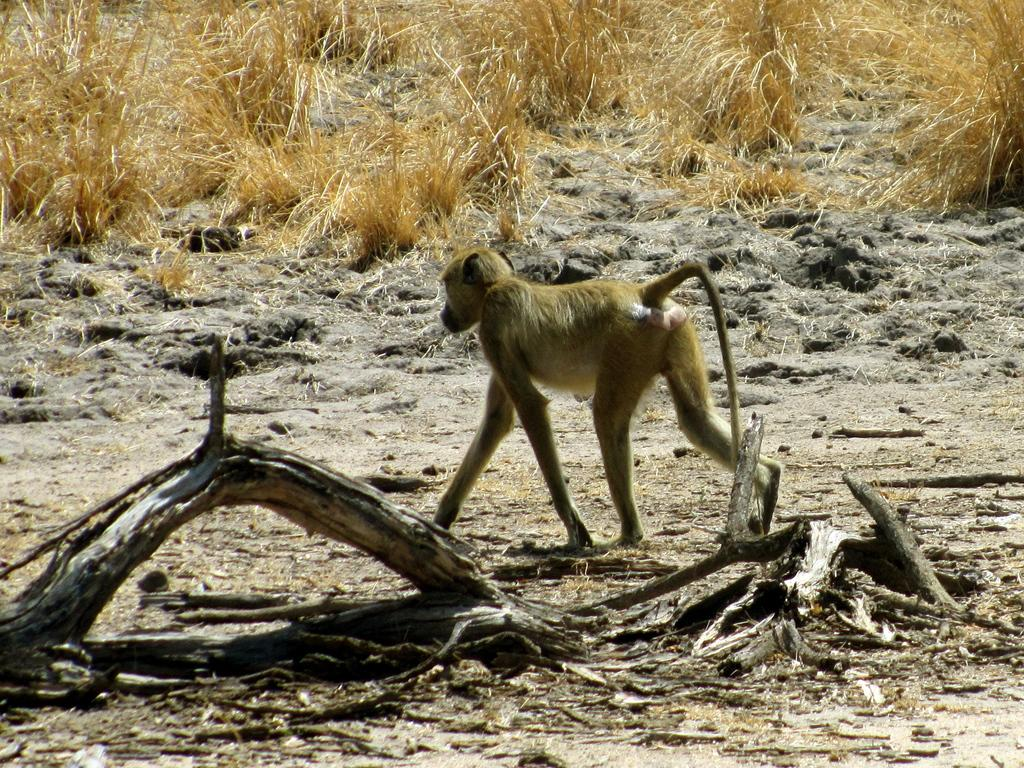What animal is walking in the middle of the image? There is a monkey walking in the middle of the image. What objects can be seen on the left side of the image? There are dried wooden sticks on the left side of the image. What type of vegetation is visible at the top of the image? There are dried plants visible at the top of the image. What type of feast is being prepared in the image? There is no indication of a feast being prepared in the image. 